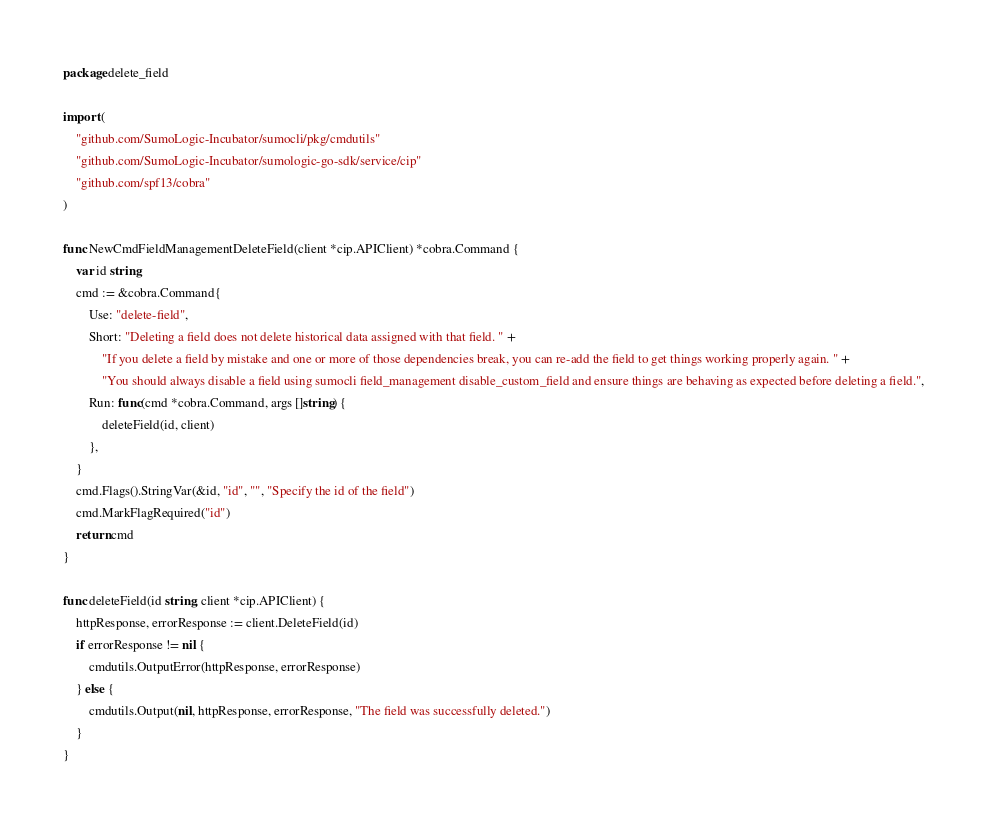Convert code to text. <code><loc_0><loc_0><loc_500><loc_500><_Go_>package delete_field

import (
	"github.com/SumoLogic-Incubator/sumocli/pkg/cmdutils"
	"github.com/SumoLogic-Incubator/sumologic-go-sdk/service/cip"
	"github.com/spf13/cobra"
)

func NewCmdFieldManagementDeleteField(client *cip.APIClient) *cobra.Command {
	var id string
	cmd := &cobra.Command{
		Use: "delete-field",
		Short: "Deleting a field does not delete historical data assigned with that field. " +
			"If you delete a field by mistake and one or more of those dependencies break, you can re-add the field to get things working properly again. " +
			"You should always disable a field using sumocli field_management disable_custom_field and ensure things are behaving as expected before deleting a field.",
		Run: func(cmd *cobra.Command, args []string) {
			deleteField(id, client)
		},
	}
	cmd.Flags().StringVar(&id, "id", "", "Specify the id of the field")
	cmd.MarkFlagRequired("id")
	return cmd
}

func deleteField(id string, client *cip.APIClient) {
	httpResponse, errorResponse := client.DeleteField(id)
	if errorResponse != nil {
		cmdutils.OutputError(httpResponse, errorResponse)
	} else {
		cmdutils.Output(nil, httpResponse, errorResponse, "The field was successfully deleted.")
	}
}
</code> 